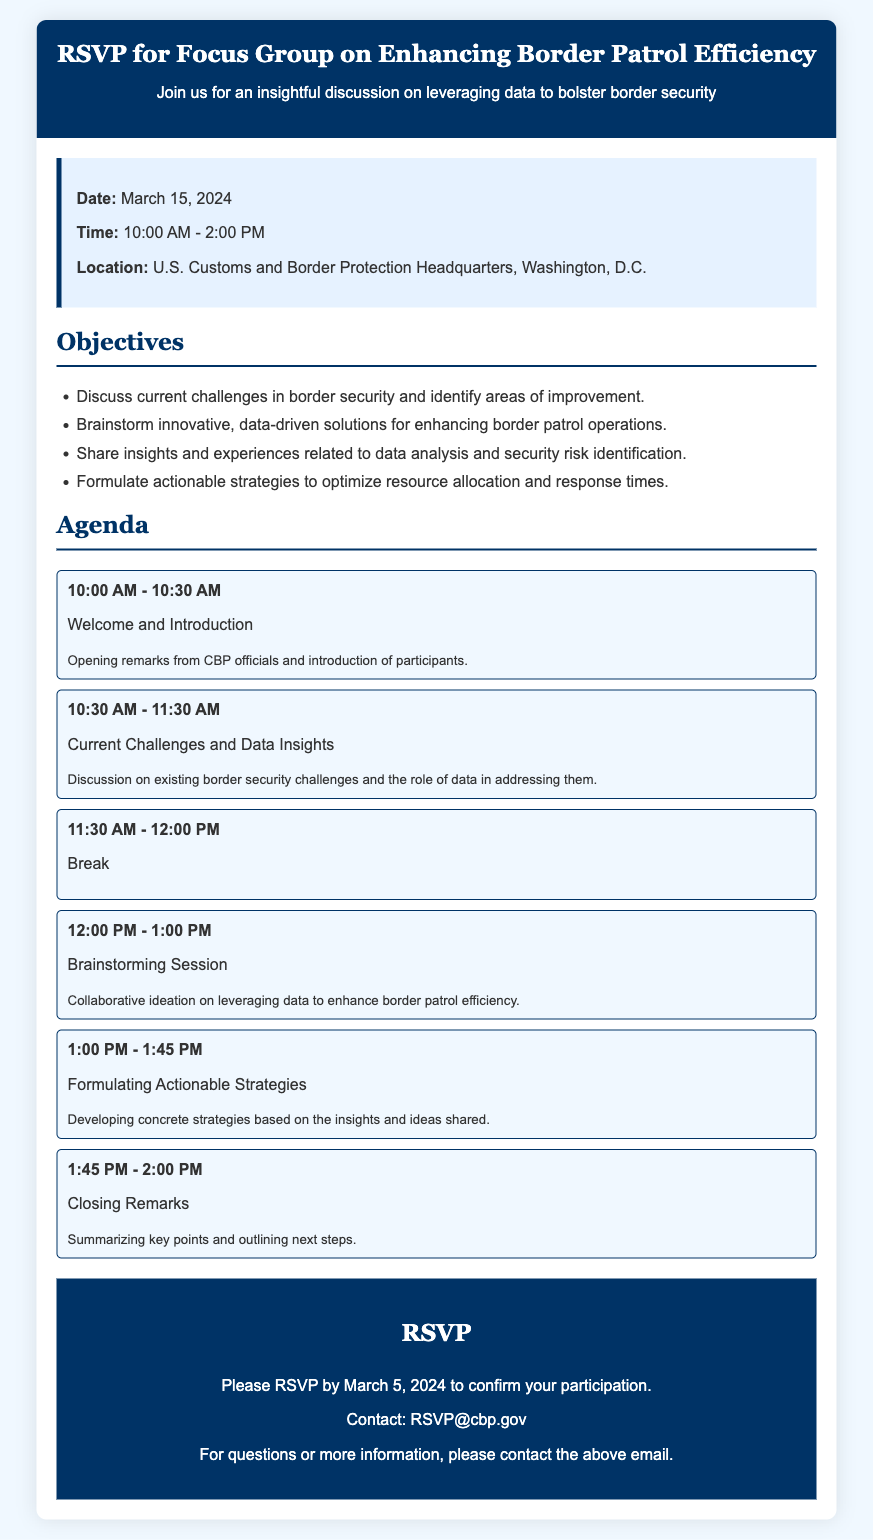What is the date of the focus group? The date is explicitly mentioned in the document under the information section as March 15, 2024.
Answer: March 15, 2024 What time does the focus group start? The starting time is provided in the information section of the document as 10:00 AM.
Answer: 10:00 AM Where is the focus group located? The location is specified in the document as U.S. Customs and Border Protection Headquarters, Washington, D.C.
Answer: U.S. Customs and Border Protection Headquarters, Washington, D.C What is one objective of the focus group? The objectives listed include discussing challenges, brainstorming solutions, sharing insights, or formulating strategies, any of which can be considered.
Answer: Discuss current challenges in border security and identify areas of improvement What is the duration of the "Brainstorming Session"? The agenda provides specific times for each section, indicating that the session lasts from 12:00 PM to 1:00 PM, which is one hour.
Answer: 1 hour When is the RSVP deadline? The RSVP deadline is clearly stated in the document as March 5, 2024.
Answer: March 5, 2024 How long is the break during the program? The agenda indicates a break period from 11:30 AM to 12:00 PM, which is 30 minutes long.
Answer: 30 minutes What is the contact email for RSVP inquiries? The document explicitly provides the contact email for RSVP inquiries as RSVP@cbp.gov.
Answer: RSVP@cbp.gov What is the last agenda item? The closing remarks are defined as the last agenda item scheduled from 1:45 PM to 2:00 PM.
Answer: Closing Remarks 